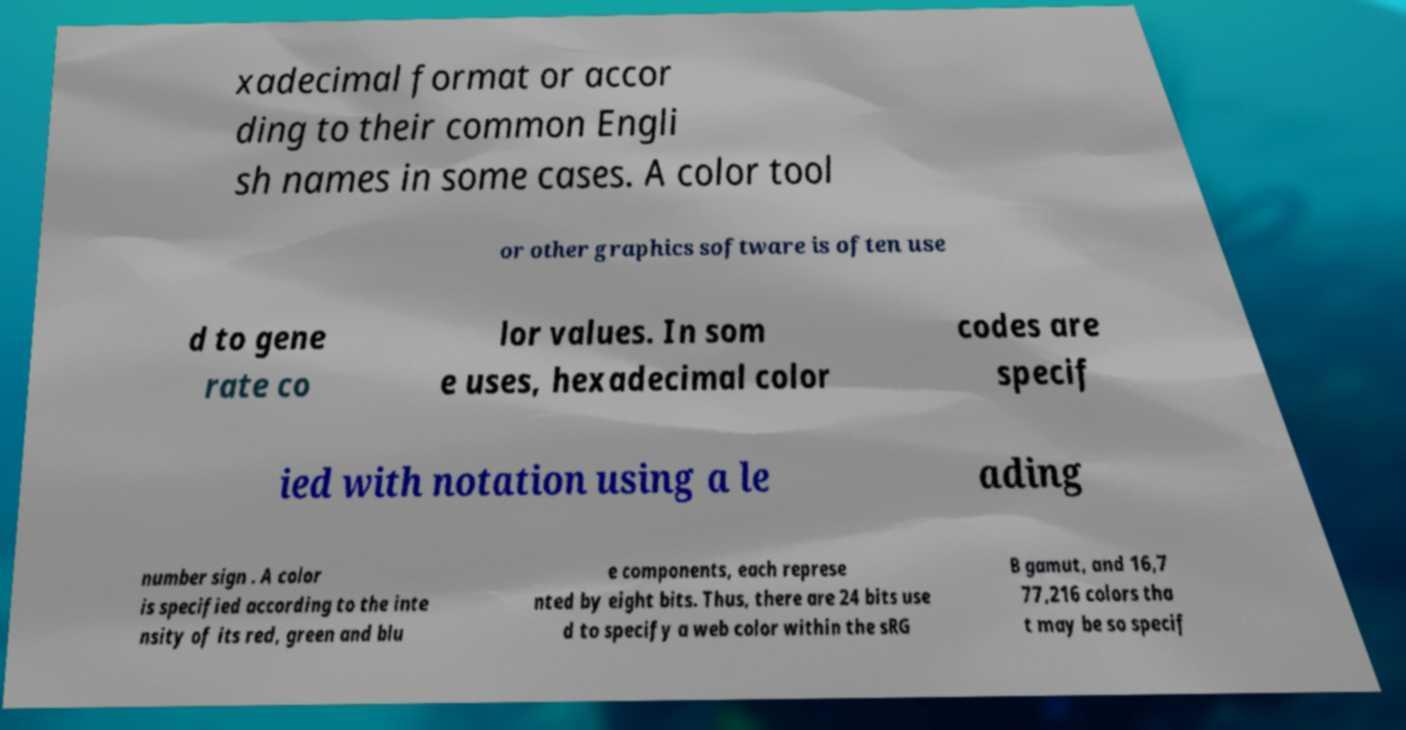Can you read and provide the text displayed in the image?This photo seems to have some interesting text. Can you extract and type it out for me? xadecimal format or accor ding to their common Engli sh names in some cases. A color tool or other graphics software is often use d to gene rate co lor values. In som e uses, hexadecimal color codes are specif ied with notation using a le ading number sign . A color is specified according to the inte nsity of its red, green and blu e components, each represe nted by eight bits. Thus, there are 24 bits use d to specify a web color within the sRG B gamut, and 16,7 77,216 colors tha t may be so specif 